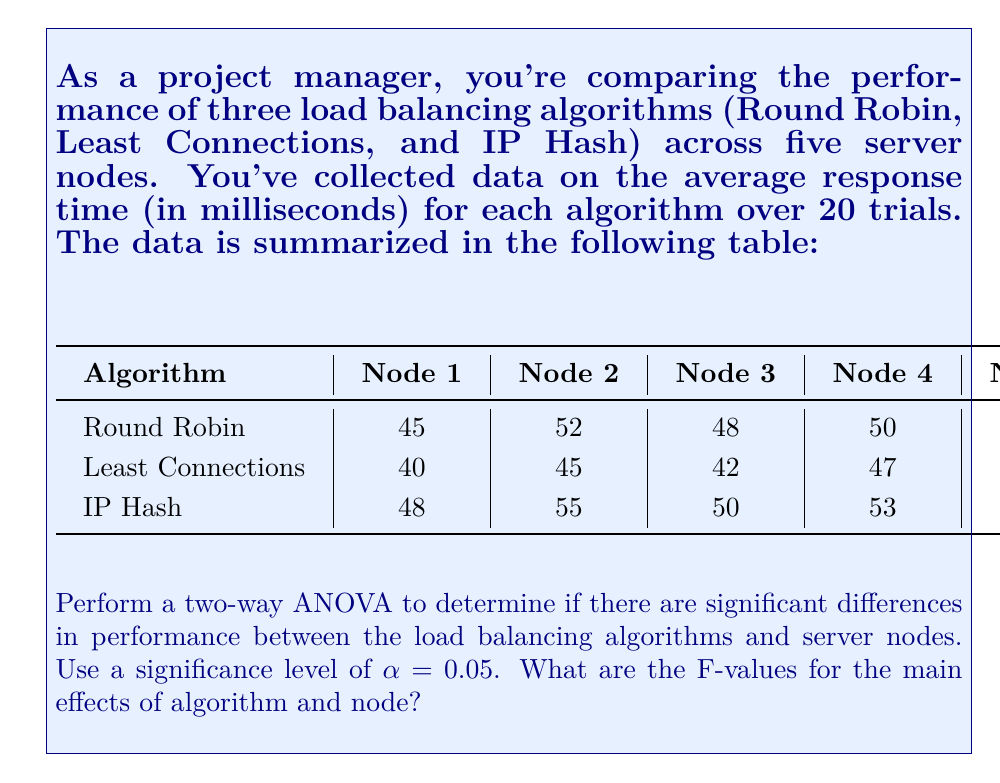What is the answer to this math problem? To perform a two-way ANOVA, we need to calculate the following:

1. Sum of Squares for Algorithm (SSA)
2. Sum of Squares for Node (SSN)
3. Sum of Squares for Interaction (SSI)
4. Sum of Squares for Error (SSE)
5. Sum of Squares Total (SST)

Let's go through the steps:

Step 1: Calculate the grand mean
$$\bar{X} = \frac{\text{Sum of all values}}{\text{Total number of values}} = \frac{689}{15} = 45.93$$

Step 2: Calculate row means (algorithm means) and column means (node means)
Row means:
- Round Robin: 50
- Least Connections: 45
- IP Hash: 52.8

Column means:
- Node 1: 44.33
- Node 2: 50.67
- Node 3: 46.67
- Node 4: 50
- Node 5: 54.67

Step 3: Calculate Sum of Squares

SSA = $n_c \sum_{i=1}^a (\bar{X_i} - \bar{X})^2$
Where $n_c$ is the number of columns (5), $a$ is the number of algorithms (3)
SSA = $5 [(50 - 45.93)^2 + (45 - 45.93)^2 + (52.8 - 45.93)^2] = 190.13$

SSN = $n_r \sum_{j=1}^b (\bar{X_j} - \bar{X})^2$
Where $n_r$ is the number of rows (3), $b$ is the number of nodes (5)
SSN = $3 [(44.33 - 45.93)^2 + (50.67 - 45.93)^2 + (46.67 - 45.93)^2 + (50 - 45.93)^2 + (54.67 - 45.93)^2] = 188.53$

SST = $\sum_{i=1}^a \sum_{j=1}^b (X_{ij} - \bar{X})^2 = 418.93$

SSI = SST - SSA - SSN = 418.93 - 190.13 - 188.53 = 40.27

SSE = 0 (since we only have one observation per cell)

Step 4: Calculate degrees of freedom
df_A = a - 1 = 2
df_N = b - 1 = 4
df_I = (a-1)(b-1) = 8
df_E = ab(n-1) = 0 (where n is the number of observations per cell)
df_T = abn - 1 = 14

Step 5: Calculate Mean Squares
MSA = SSA / df_A = 190.13 / 2 = 95.065
MSN = SSN / df_N = 188.53 / 4 = 47.1325
MSI = SSI / df_I = 40.27 / 8 = 5.03375

Step 6: Calculate F-values
F_A = MSA / MSI = 95.065 / 5.03375 = 18.89
F_N = MSN / MSI = 47.1325 / 5.03375 = 9.36
Answer: The F-value for the main effect of algorithm is 18.89, and the F-value for the main effect of node is 9.36. 